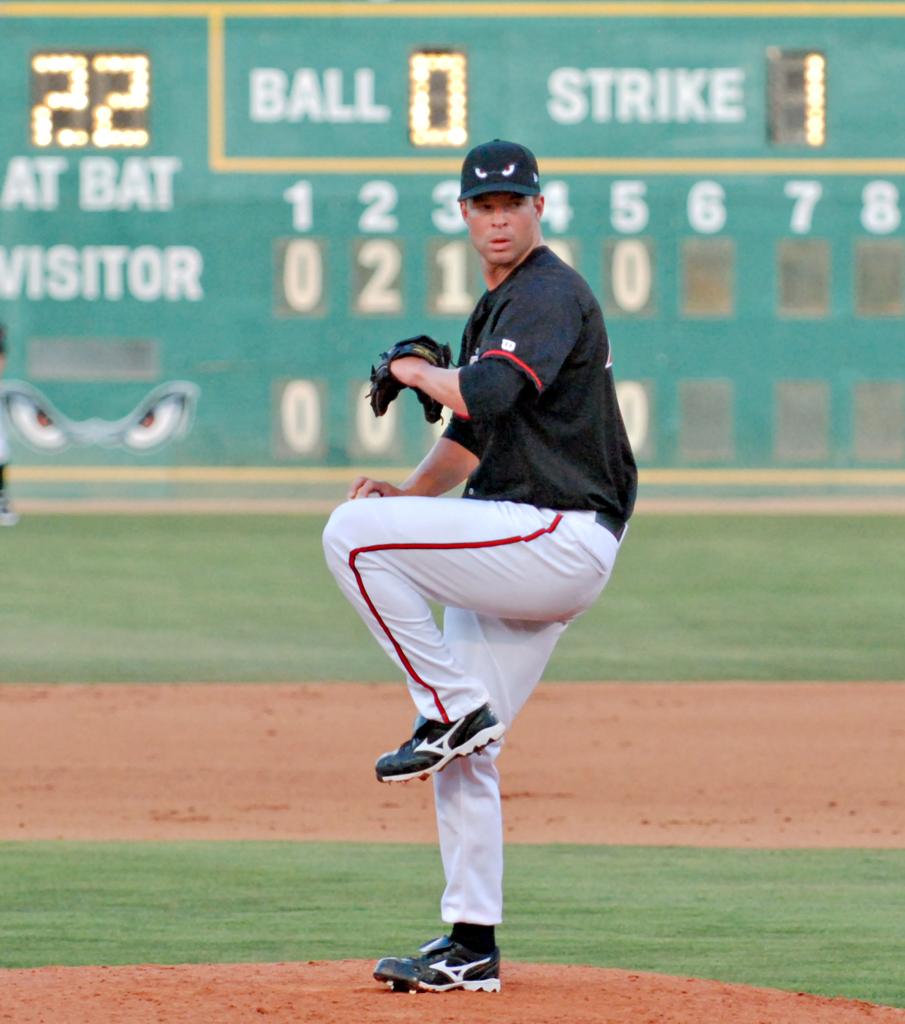How many strikes have been thrown so far?
Provide a short and direct response. 1. 